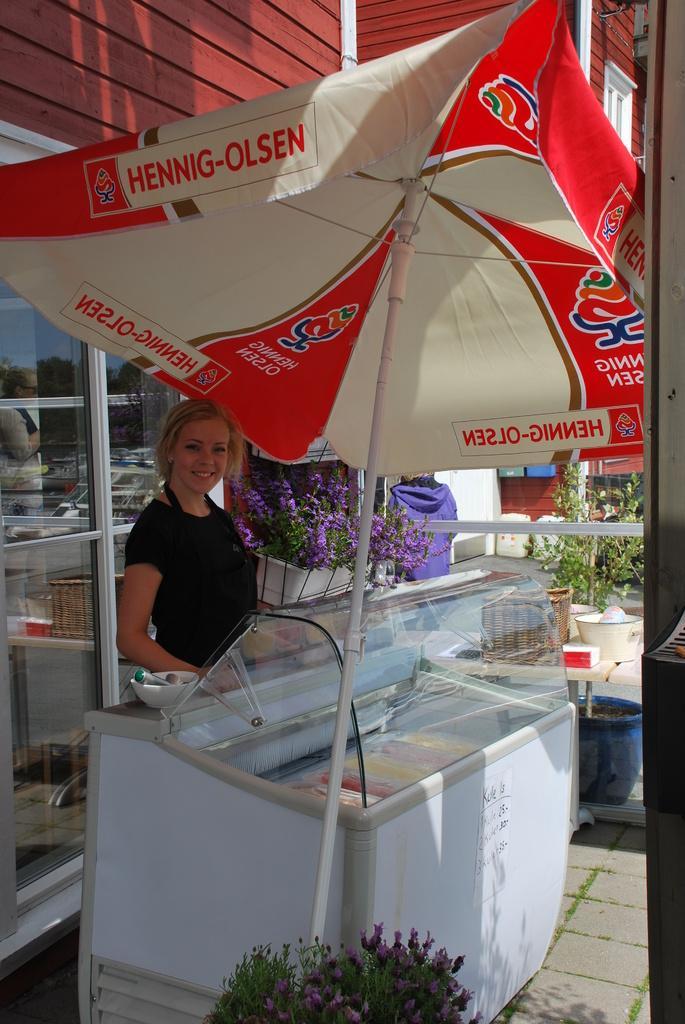Could you give a brief overview of what you see in this image? In this image we can see a woman and she is smiling. Here we can see an umbrella, plants, flowers, glasses, bowl, deep freezer, and other objects. In the background we can see a building. 